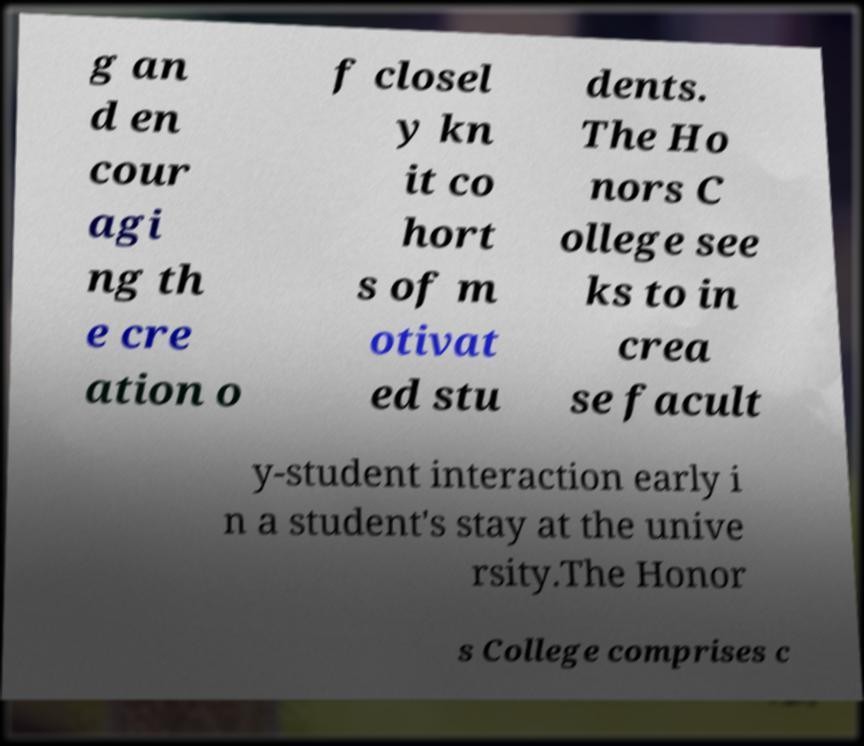Could you assist in decoding the text presented in this image and type it out clearly? g an d en cour agi ng th e cre ation o f closel y kn it co hort s of m otivat ed stu dents. The Ho nors C ollege see ks to in crea se facult y-student interaction early i n a student's stay at the unive rsity.The Honor s College comprises c 